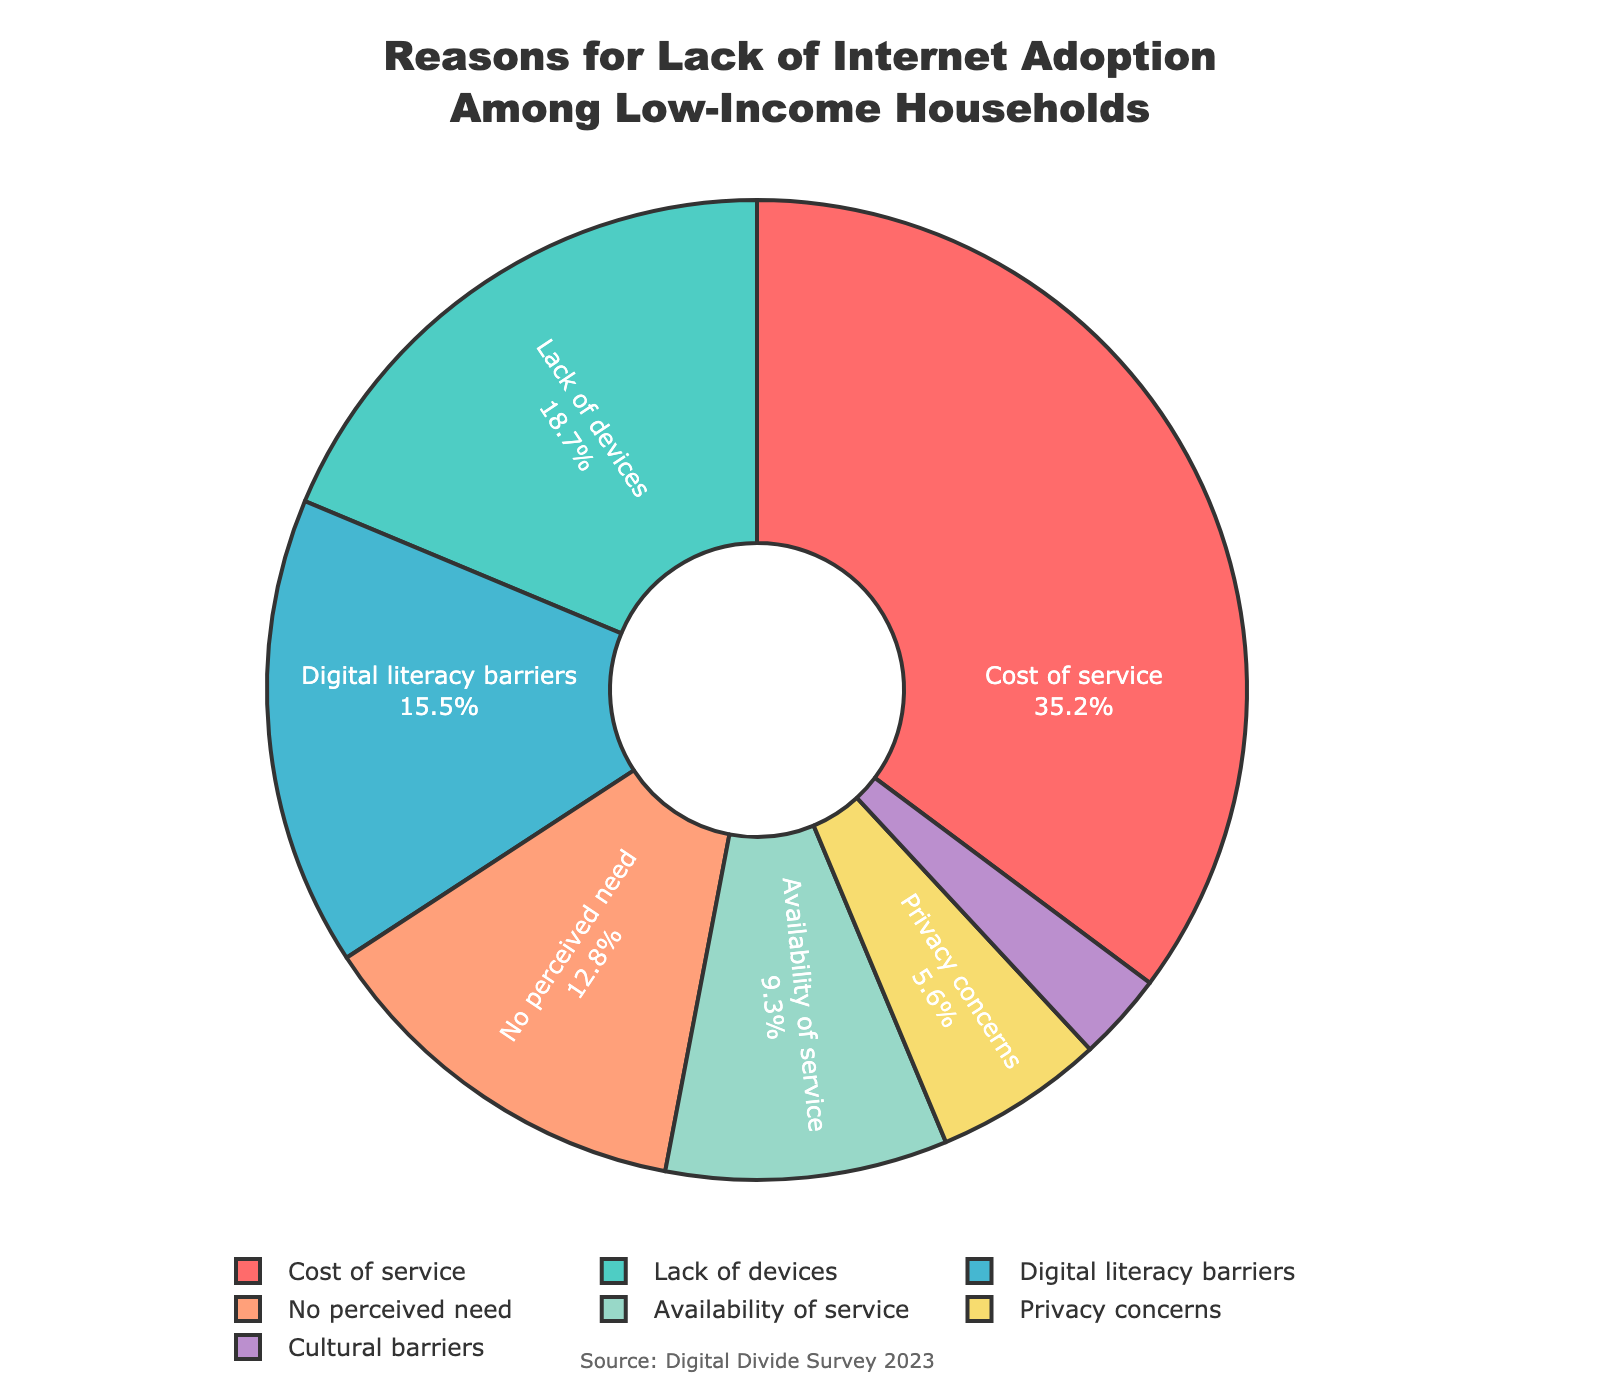What is the most common reason for the lack of internet adoption among low-income households? The slice representing "Cost of service" is the largest among all segments, indicating it's the most common reason.
Answer: Cost of service What percentage of low-income households cite "Lack of devices" as a reason for not adopting the internet? According to the pie chart, the segment for "Lack of devices" shows 18.7%.
Answer: 18.7% Which two reasons combined account for more than half of the reasons for lack of internet adoption among low-income households? "Cost of service" accounts for 35.2% and "Lack of devices" accounts for 18.7%. Adding these gives 35.2% + 18.7% = 53.9%, which is more than half.
Answer: Cost of service and Lack of devices Is "Privacy concerns" a more common reason than "Cultural barriers" for not having internet access? The pie chart shows "Privacy concerns" at 5.6% and "Cultural barriers" at 2.9%. Since 5.6% is greater than 2.9%, "Privacy concerns" is a more common reason.
Answer: Yes What is the total percentage of respondents citing either "No perceived need" or "Availability of service" as their reason for not adopting the internet? "No perceived need" accounts for 12.8%, and "Availability of service" accounts for 9.3%. Adding these gives 12.8% + 9.3% = 22.1%.
Answer: 22.1% Which reason has the smallest percentage and what color represents it in the chart? "Cultural barriers" has the smallest percentage at 2.9%. The slice representing "Cultural barriers" is the smallest one and typically, in color-coded charts, darker colors like purple are used for smaller percentages.
Answer: Cultural barriers, purple How much more common is "Digital literacy barriers" than "Privacy concerns"? According to the pie chart, "Digital literacy barriers" is 15.5% and "Privacy concerns" is 5.6%. Subtracting 5.6% from 15.5% gives 15.5% - 5.6% = 9.9%.
Answer: 9.9% What percentage of reasons fall into categories that are below 10% individually? "Availability of service" is 9.3%, "Privacy concerns" is 5.6%, and "Cultural barriers" is 2.9%. Adding these gives 9.3% + 5.6% + 2.9% = 17.8%.
Answer: 17.8% Among the reasons listed, which one is second most common and what is its percentage? The second largest segment after "Cost of service" is "Lack of devices" which is marked at 18.7%.
Answer: Lack of devices, 18.7% Considering reasons that account for under 20%, what is their total sum percentage? "Lack of devices" (18.7%), "Digital literacy barriers" (15.5%), "No perceived need" (12.8%), "Availability of service" (9.3%), "Privacy concerns" (5.6%), and "Cultural barriers" (2.9%). Adding these gives 18.7% + 15.5% + 12.8% + 9.3% + 5.6% + 2.9% = 64.8%.
Answer: 64.8% 